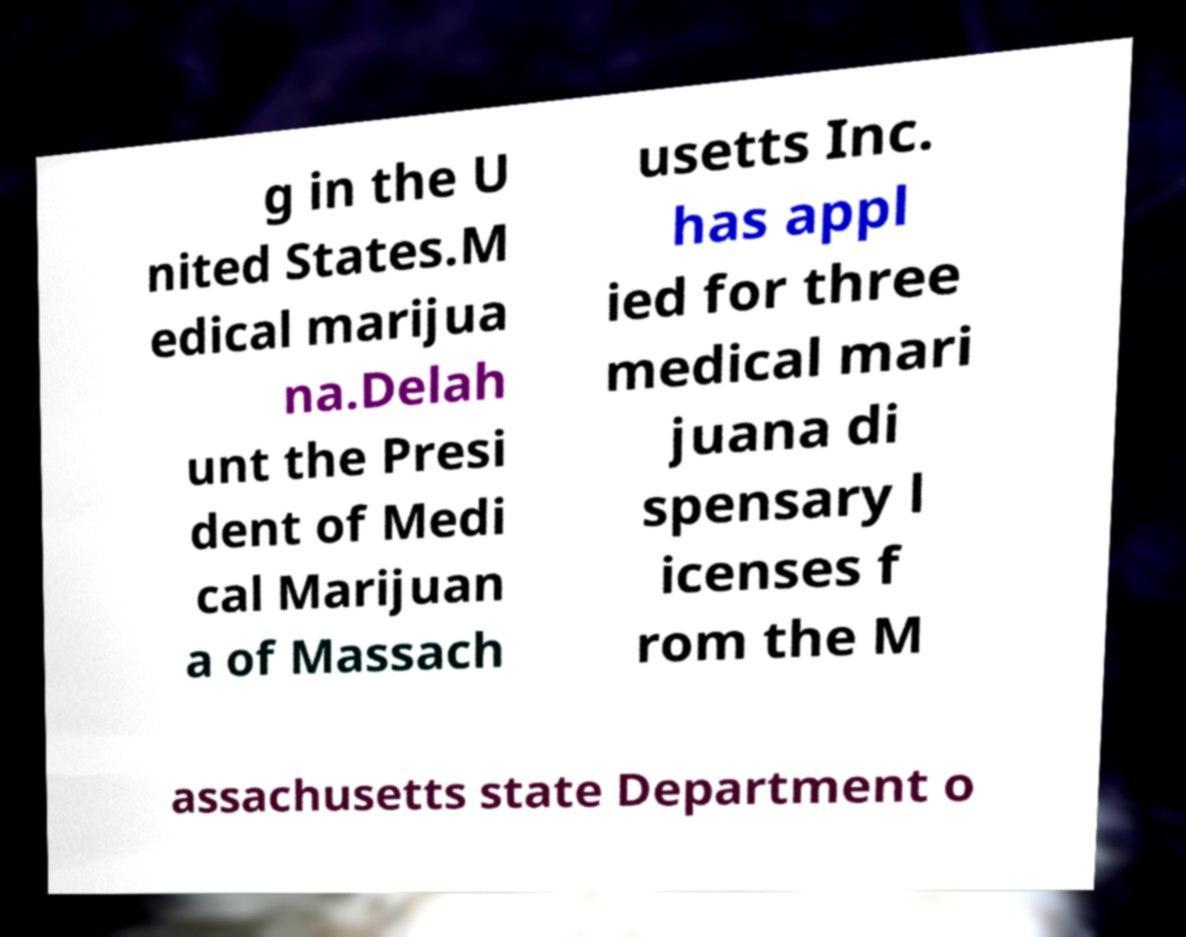There's text embedded in this image that I need extracted. Can you transcribe it verbatim? g in the U nited States.M edical marijua na.Delah unt the Presi dent of Medi cal Marijuan a of Massach usetts Inc. has appl ied for three medical mari juana di spensary l icenses f rom the M assachusetts state Department o 